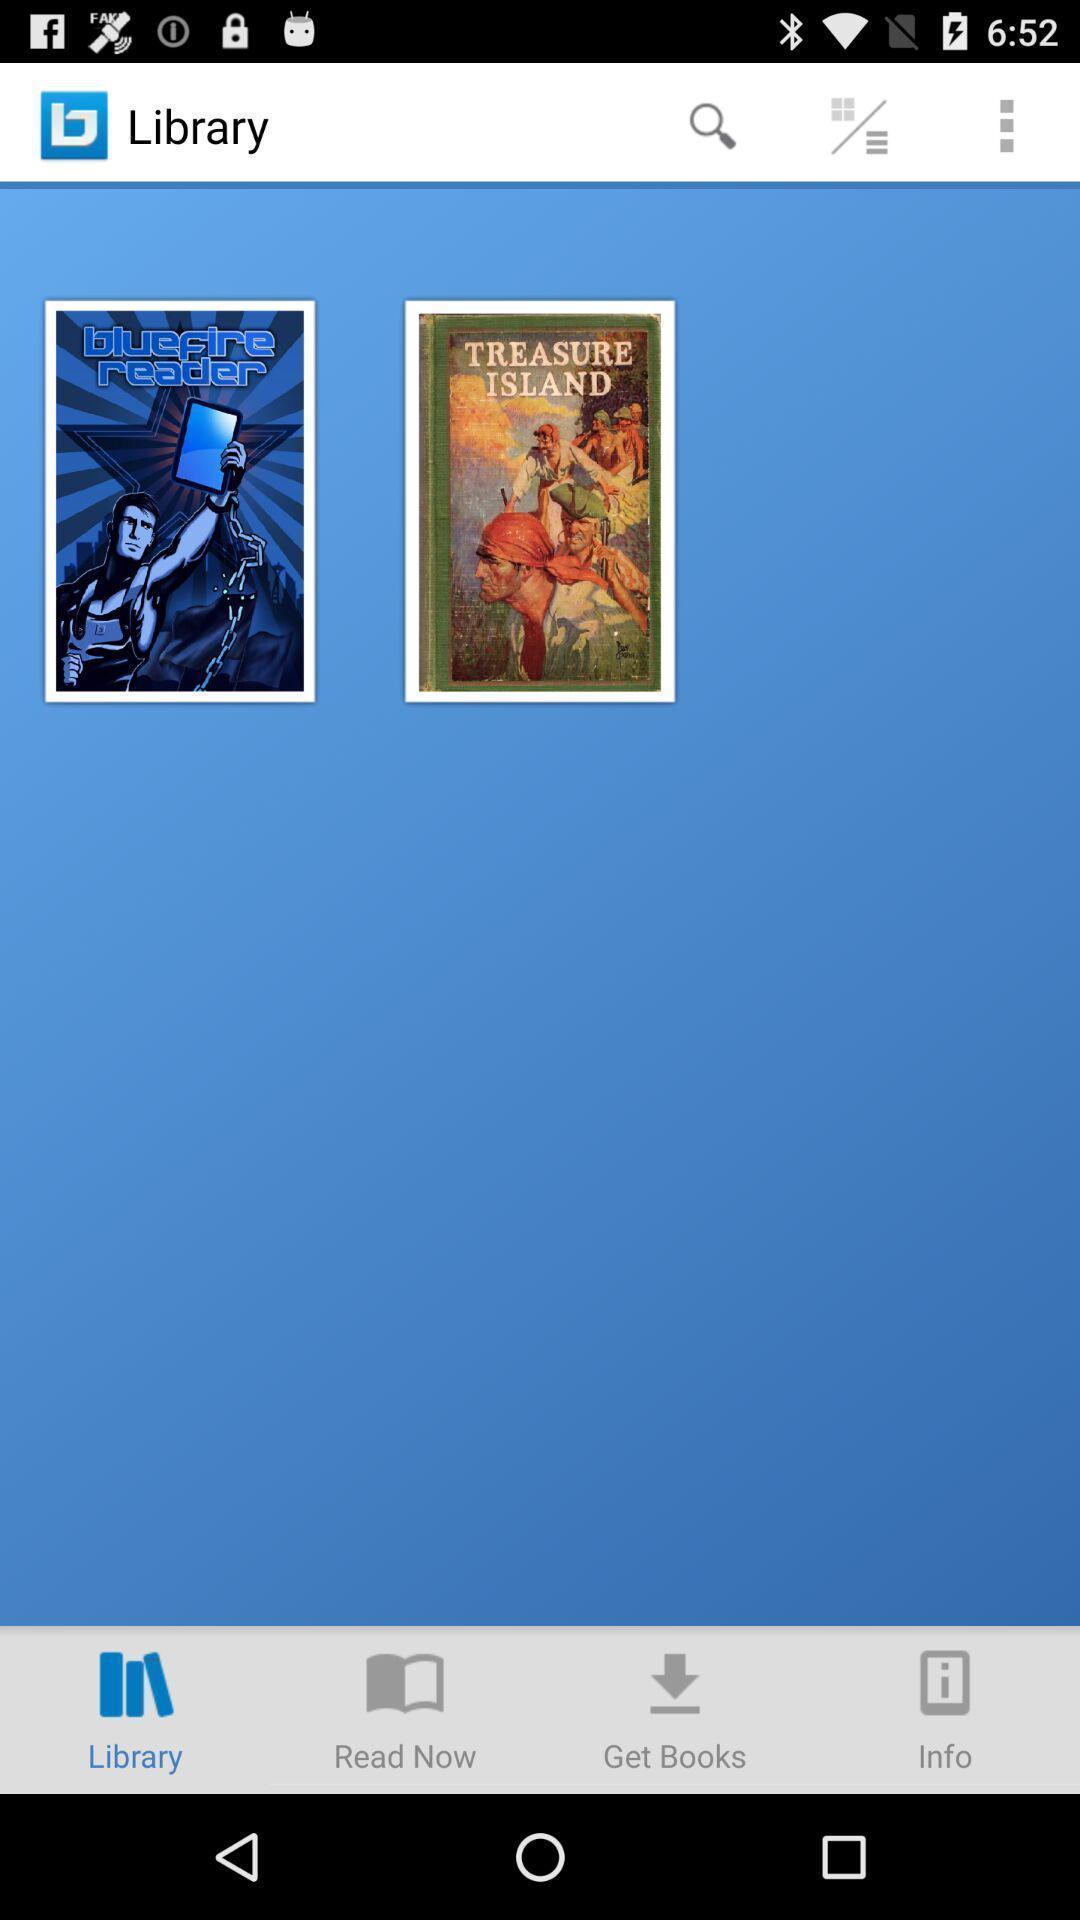Give me a narrative description of this picture. Page showing your library list in the book reading app. 